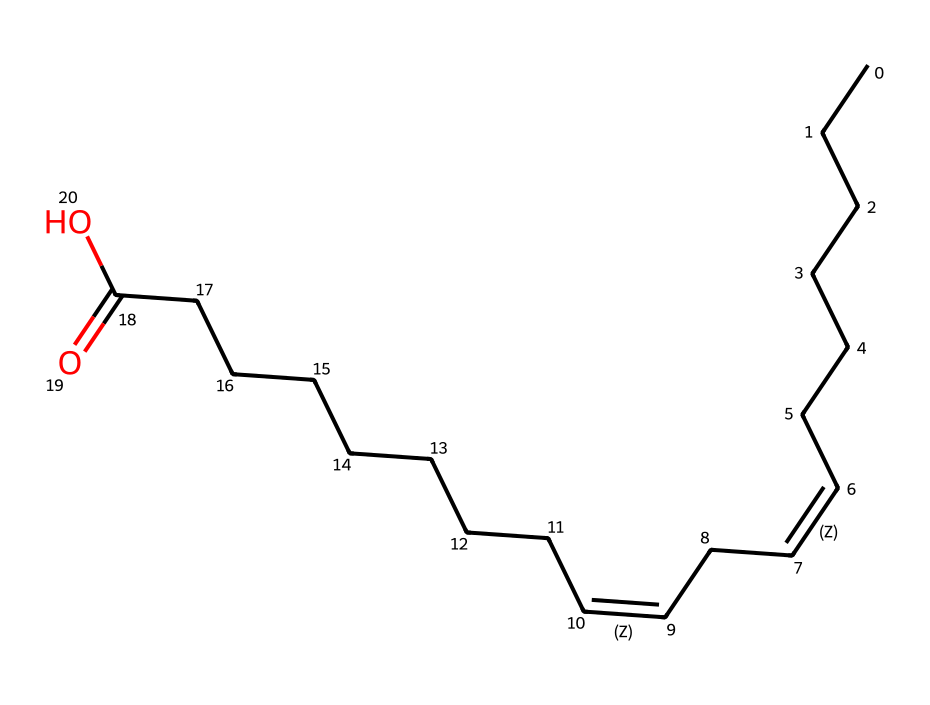What type of fatty acid is represented in this structure? The chemical structure contains multiple cis and trans double bonds as indicated by the slashes used in the SMILES notation, suggesting it’s a polyunsaturated fatty acid.
Answer: polyunsaturated fatty acid How many double bonds are present in this fatty acid? The structure contains two instances of the /C=C\ sequence, indicating two double bonds.
Answer: two Which geometric isomer is indicated by the slashes in the structure? The structure primarily describes a trans configuration due to the way the double bonds are represented (with / and \), where trans indicates hydrogen atoms opposite each other.
Answer: trans What is the longest carbon chain in this fatty acid? Counting the carbon atoms, there are a total of 18 carbon atoms in the longest continuous chain.
Answer: eighteen What functional group is present at the end of this fatty acid? The presence of "(=O)O" in the SMILES indicates a carboxylic acid functional group at the terminal end of the fatty acid chain.
Answer: carboxylic acid How does the arrangement of hydrogen atoms affect the melting point of this fatty acid? In trans geometric isomers, the arrangement of hydrogen atoms, being opposite, typically allows for tighter packing and a higher melting point compared to the cis form.
Answer: higher melting point 